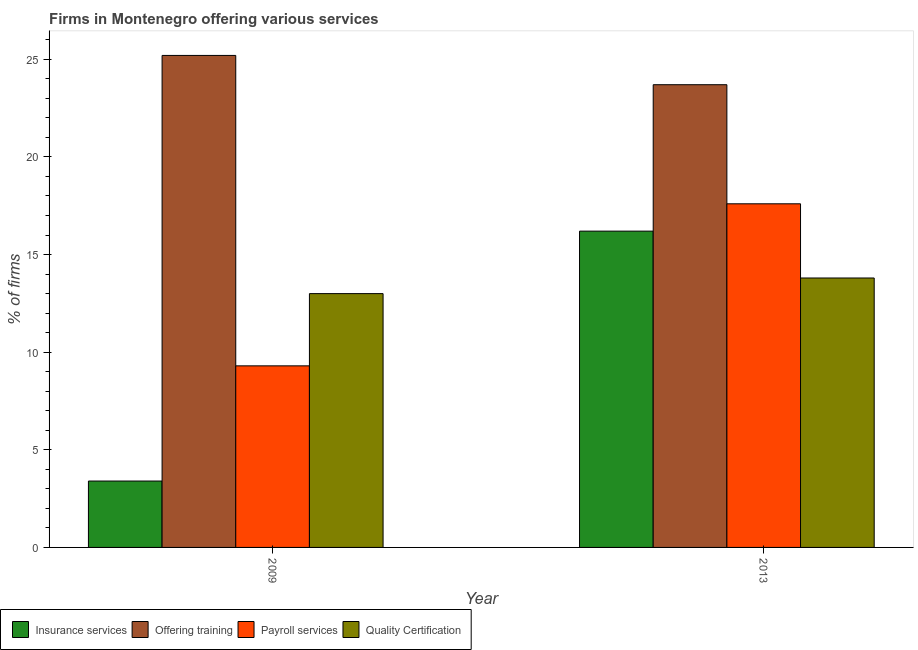Are the number of bars on each tick of the X-axis equal?
Your answer should be very brief. Yes. How many bars are there on the 2nd tick from the right?
Give a very brief answer. 4. What is the percentage of firms offering training in 2013?
Offer a terse response. 23.7. Across all years, what is the maximum percentage of firms offering training?
Provide a short and direct response. 25.2. In which year was the percentage of firms offering training maximum?
Provide a short and direct response. 2009. What is the total percentage of firms offering insurance services in the graph?
Provide a short and direct response. 19.6. What is the difference between the percentage of firms offering training in 2009 and that in 2013?
Ensure brevity in your answer.  1.5. What is the average percentage of firms offering training per year?
Keep it short and to the point. 24.45. In the year 2013, what is the difference between the percentage of firms offering payroll services and percentage of firms offering training?
Keep it short and to the point. 0. In how many years, is the percentage of firms offering payroll services greater than 8 %?
Provide a succinct answer. 2. What is the ratio of the percentage of firms offering quality certification in 2009 to that in 2013?
Your response must be concise. 0.94. What does the 1st bar from the left in 2013 represents?
Offer a terse response. Insurance services. What does the 2nd bar from the right in 2009 represents?
Your answer should be very brief. Payroll services. Is it the case that in every year, the sum of the percentage of firms offering insurance services and percentage of firms offering training is greater than the percentage of firms offering payroll services?
Your answer should be very brief. Yes. Are all the bars in the graph horizontal?
Give a very brief answer. No. How many years are there in the graph?
Your answer should be very brief. 2. What is the difference between two consecutive major ticks on the Y-axis?
Keep it short and to the point. 5. Where does the legend appear in the graph?
Offer a terse response. Bottom left. How are the legend labels stacked?
Make the answer very short. Horizontal. What is the title of the graph?
Give a very brief answer. Firms in Montenegro offering various services . What is the label or title of the Y-axis?
Offer a very short reply. % of firms. What is the % of firms in Insurance services in 2009?
Your response must be concise. 3.4. What is the % of firms in Offering training in 2009?
Offer a very short reply. 25.2. What is the % of firms in Payroll services in 2009?
Give a very brief answer. 9.3. What is the % of firms of Insurance services in 2013?
Make the answer very short. 16.2. What is the % of firms of Offering training in 2013?
Provide a short and direct response. 23.7. What is the % of firms in Payroll services in 2013?
Provide a short and direct response. 17.6. Across all years, what is the maximum % of firms of Insurance services?
Provide a succinct answer. 16.2. Across all years, what is the maximum % of firms in Offering training?
Keep it short and to the point. 25.2. Across all years, what is the minimum % of firms of Insurance services?
Offer a terse response. 3.4. Across all years, what is the minimum % of firms of Offering training?
Your response must be concise. 23.7. Across all years, what is the minimum % of firms in Quality Certification?
Your answer should be compact. 13. What is the total % of firms in Insurance services in the graph?
Provide a succinct answer. 19.6. What is the total % of firms in Offering training in the graph?
Your response must be concise. 48.9. What is the total % of firms of Payroll services in the graph?
Your response must be concise. 26.9. What is the total % of firms in Quality Certification in the graph?
Keep it short and to the point. 26.8. What is the difference between the % of firms in Insurance services in 2009 and that in 2013?
Your response must be concise. -12.8. What is the difference between the % of firms in Payroll services in 2009 and that in 2013?
Ensure brevity in your answer.  -8.3. What is the difference between the % of firms of Insurance services in 2009 and the % of firms of Offering training in 2013?
Keep it short and to the point. -20.3. What is the difference between the % of firms in Insurance services in 2009 and the % of firms in Quality Certification in 2013?
Ensure brevity in your answer.  -10.4. What is the difference between the % of firms of Offering training in 2009 and the % of firms of Quality Certification in 2013?
Your answer should be compact. 11.4. What is the average % of firms of Insurance services per year?
Offer a terse response. 9.8. What is the average % of firms in Offering training per year?
Keep it short and to the point. 24.45. What is the average % of firms of Payroll services per year?
Your answer should be very brief. 13.45. In the year 2009, what is the difference between the % of firms in Insurance services and % of firms in Offering training?
Your answer should be very brief. -21.8. In the year 2009, what is the difference between the % of firms of Insurance services and % of firms of Quality Certification?
Offer a very short reply. -9.6. In the year 2009, what is the difference between the % of firms of Offering training and % of firms of Payroll services?
Provide a succinct answer. 15.9. In the year 2013, what is the difference between the % of firms of Insurance services and % of firms of Payroll services?
Offer a terse response. -1.4. In the year 2013, what is the difference between the % of firms of Offering training and % of firms of Quality Certification?
Offer a terse response. 9.9. What is the ratio of the % of firms in Insurance services in 2009 to that in 2013?
Provide a short and direct response. 0.21. What is the ratio of the % of firms in Offering training in 2009 to that in 2013?
Give a very brief answer. 1.06. What is the ratio of the % of firms of Payroll services in 2009 to that in 2013?
Offer a very short reply. 0.53. What is the ratio of the % of firms in Quality Certification in 2009 to that in 2013?
Offer a terse response. 0.94. What is the difference between the highest and the second highest % of firms of Insurance services?
Offer a terse response. 12.8. What is the difference between the highest and the second highest % of firms of Payroll services?
Keep it short and to the point. 8.3. What is the difference between the highest and the lowest % of firms in Insurance services?
Your response must be concise. 12.8. What is the difference between the highest and the lowest % of firms in Offering training?
Ensure brevity in your answer.  1.5. What is the difference between the highest and the lowest % of firms in Quality Certification?
Make the answer very short. 0.8. 